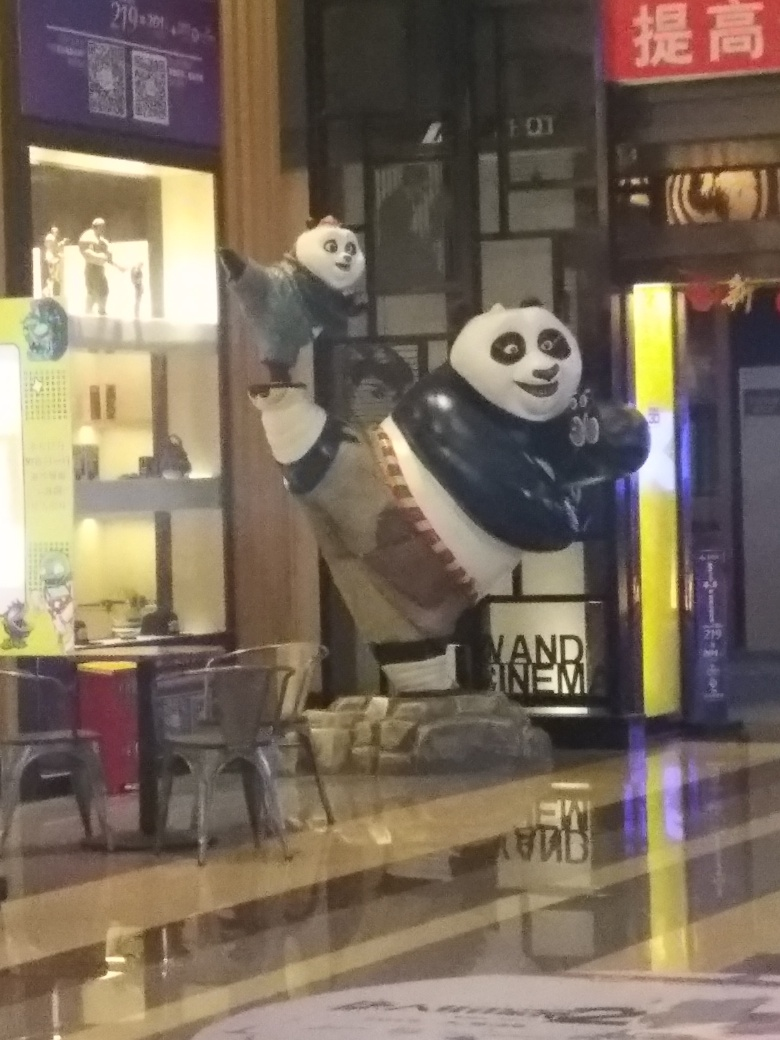What is the purpose of this panda figure? The panda figure is likely part of a marketing or promotional campaign designed to attract attention to the establishment or to the theme being advertised, using the panda's appealing and recognizable image as a draw. Does this prominent display suggest that the establishment celebrates conservation or cultural themes related to pandas? Yes, the prominent placement of the panda figures could indeed suggest that the establishment is drawing attention to themes of conservation, especially given the panda's status as a conservation symbol, or it may be highlighting cultural connections, as pandas are strongly associated with China. 